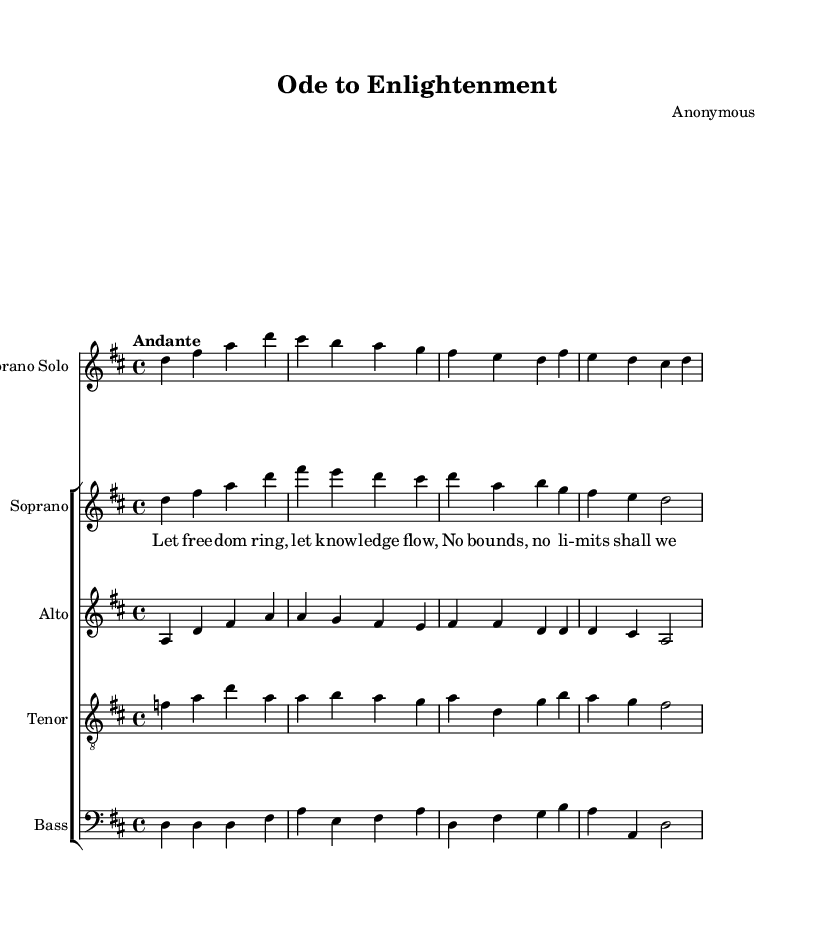What is the key signature of this music? The key signature is two sharps (F# and C#), indicating that the piece is in D major.
Answer: D major What is the time signature of this music? The time signature is 4/4, meaning there are four beats in each measure and the quarter note gets one beat.
Answer: 4/4 What is the tempo marking of this piece? The tempo marking is "Andante," which suggests a moderately slow pace, generally around 76-108 beats per minute.
Answer: Andante Which voice part has a solo line? The soprano solo part is indicated as the only solo voice, distinguishing it from the choral voices in the rest of the piece.
Answer: Soprano Solo What is the text of the first verse? The lyrics for the first verse are "Let freedom ring, let knowledge flow, no bounds, no limits shall we know," highlighting the theme of intellectual freedom.
Answer: Let freedom ring, let knowledge flow How many voice parts are included in the score? There are five voice parts: Soprano Solo, Soprano, Alto, Tenor, and Bass, making it a choral work with a solo component.
Answer: Five What is the overall theme represented in the music? The theme represented is the pursuit of knowledge and intellectual freedom, as conveyed through the lyrics and musical structure.
Answer: Pursuit of knowledge and intellectual freedom 